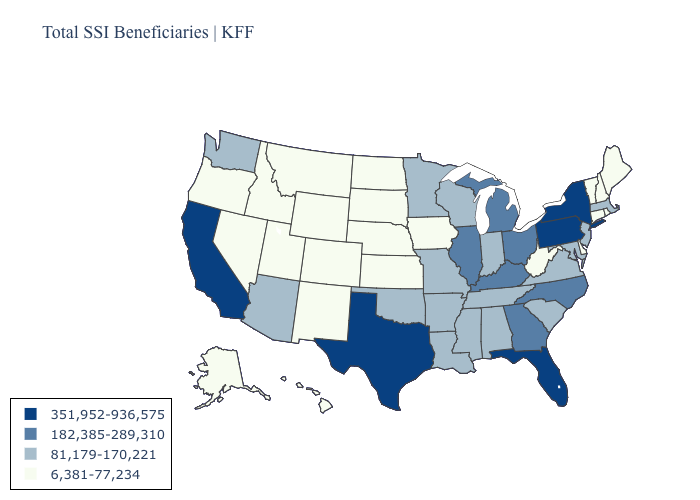Does Texas have the highest value in the South?
Be succinct. Yes. Name the states that have a value in the range 182,385-289,310?
Write a very short answer. Georgia, Illinois, Kentucky, Michigan, North Carolina, Ohio. Does West Virginia have the lowest value in the USA?
Give a very brief answer. Yes. What is the highest value in states that border Mississippi?
Concise answer only. 81,179-170,221. Does Alabama have a lower value than Illinois?
Write a very short answer. Yes. Name the states that have a value in the range 81,179-170,221?
Give a very brief answer. Alabama, Arizona, Arkansas, Indiana, Louisiana, Maryland, Massachusetts, Minnesota, Mississippi, Missouri, New Jersey, Oklahoma, South Carolina, Tennessee, Virginia, Washington, Wisconsin. What is the value of New Hampshire?
Keep it brief. 6,381-77,234. Name the states that have a value in the range 351,952-936,575?
Quick response, please. California, Florida, New York, Pennsylvania, Texas. What is the value of Nevada?
Concise answer only. 6,381-77,234. What is the lowest value in the USA?
Short answer required. 6,381-77,234. Name the states that have a value in the range 182,385-289,310?
Write a very short answer. Georgia, Illinois, Kentucky, Michigan, North Carolina, Ohio. Does Arkansas have a higher value than North Carolina?
Short answer required. No. Does Wisconsin have the same value as New York?
Concise answer only. No. Does Iowa have the lowest value in the USA?
Answer briefly. Yes. What is the lowest value in the USA?
Answer briefly. 6,381-77,234. 